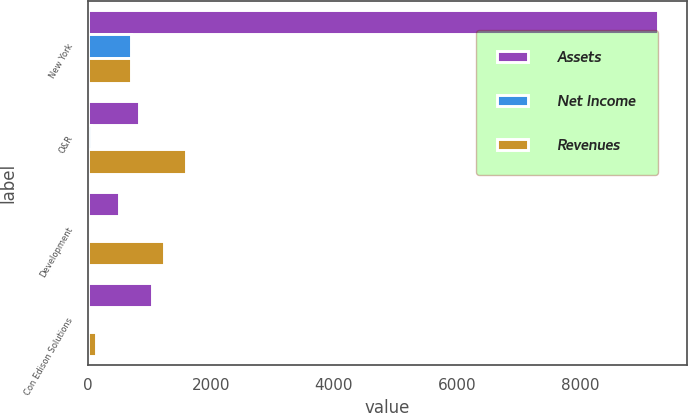Convert chart. <chart><loc_0><loc_0><loc_500><loc_500><stacked_bar_chart><ecel><fcel>New York<fcel>O&R<fcel>Development<fcel>Con Edison Solutions<nl><fcel>Assets<fcel>9272<fcel>824<fcel>512<fcel>1040<nl><fcel>Net Income<fcel>694<fcel>49<fcel>6<fcel>5<nl><fcel>Revenues<fcel>694<fcel>1588<fcel>1240<fcel>139<nl></chart> 